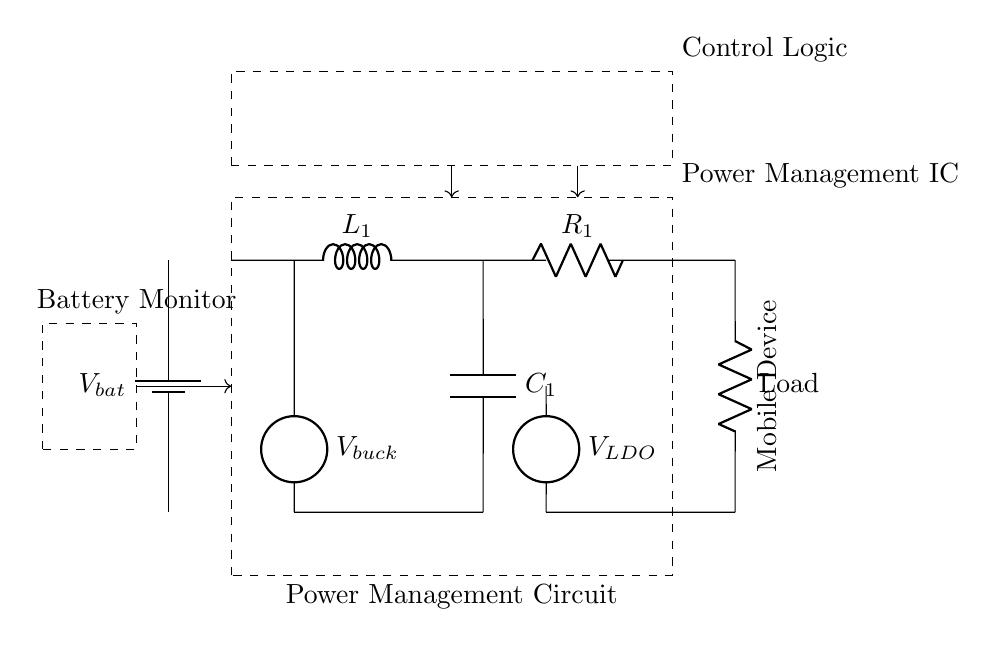What is the type of circuit used for power management? The circuit shown is a power management circuit, which is specifically designed to optimize battery life and energy efficiency in mobile devices. This type of circuit generally incorporates components like voltage regulators, buck converters, and monitoring systems.
Answer: Power management circuit What does the component marked as Load represent? The "Load" in the circuit diagram signifies the part of the circuit that consumes power, which is typically the electronic components or functionalities in a mobile device utilizing the provided power from the battery and regulators.
Answer: Load What is the purpose of the LDO regulator in this circuit? The LDO (Low Drop-Out) regulator is used to provide a stable output voltage, even when the input voltage is very close to the output voltage. It ensures that the devices connected to it receive a consistent voltage level for proper operation, improving energy efficiency.
Answer: Stable output voltage How many sources are present in this circuit? There are two sources present in the circuit: one is the battery supplying power, and the other is the buck converter delivering a lower output voltage for efficient power use.
Answer: Two sources Which component is responsible for energy storage in the circuit? The component labeled "C1" is a capacitor, which is responsible for energy storage. It stores electrical energy when there is excess voltage and releases it when needed, helping to stabilize the voltage supplied to the load.
Answer: C1 What is the function of the control logic in the circuit? The control logic acts as a management system that regulates various operations of the power management components. It assures that energy is efficiently directed based on the device's requirements, enhancing battery performance and lifespan.
Answer: Regulating operations What is the role of the battery monitor? The battery monitor measures the battery voltage and provides data to the control logic, ensuring safe operation by preventing over-discharge and helping to maintain optimal performance of the power management circuit.
Answer: Measures battery voltage 